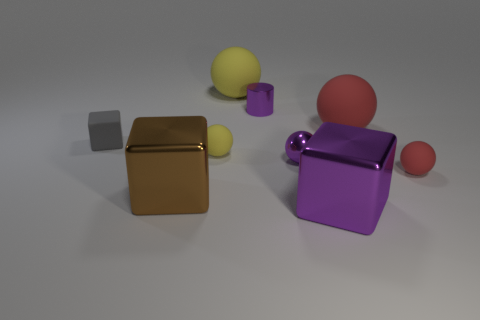There is a small matte thing right of the big yellow matte thing; what shape is it?
Offer a terse response. Sphere. There is a purple metallic thing behind the thing on the left side of the metal block on the left side of the tiny purple cylinder; what size is it?
Offer a terse response. Small. Does the tiny yellow rubber object have the same shape as the brown object?
Ensure brevity in your answer.  No. What is the size of the shiny thing that is both in front of the purple metallic ball and on the right side of the brown thing?
Give a very brief answer. Large. What is the material of the big purple object that is the same shape as the brown thing?
Ensure brevity in your answer.  Metal. What is the material of the big ball that is to the left of the large rubber ball in front of the tiny purple metal cylinder?
Your response must be concise. Rubber. Does the small gray rubber thing have the same shape as the small thing that is behind the small gray matte object?
Your answer should be very brief. No. How many metal objects are small yellow objects or brown cubes?
Offer a very short reply. 1. What is the color of the big cube that is behind the large metallic object on the right side of the big matte ball that is behind the cylinder?
Your answer should be very brief. Brown. What number of other things are there of the same material as the tiny gray thing
Your answer should be very brief. 4. 